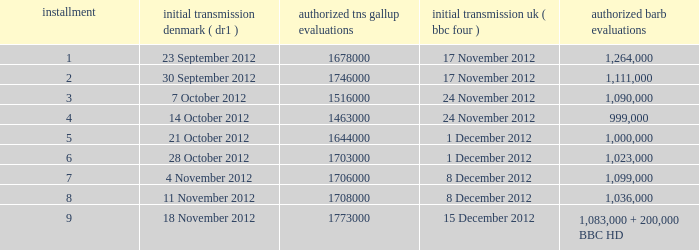When was the episode with a 1,036,000 BARB rating first aired in Denmark? 11 November 2012. 